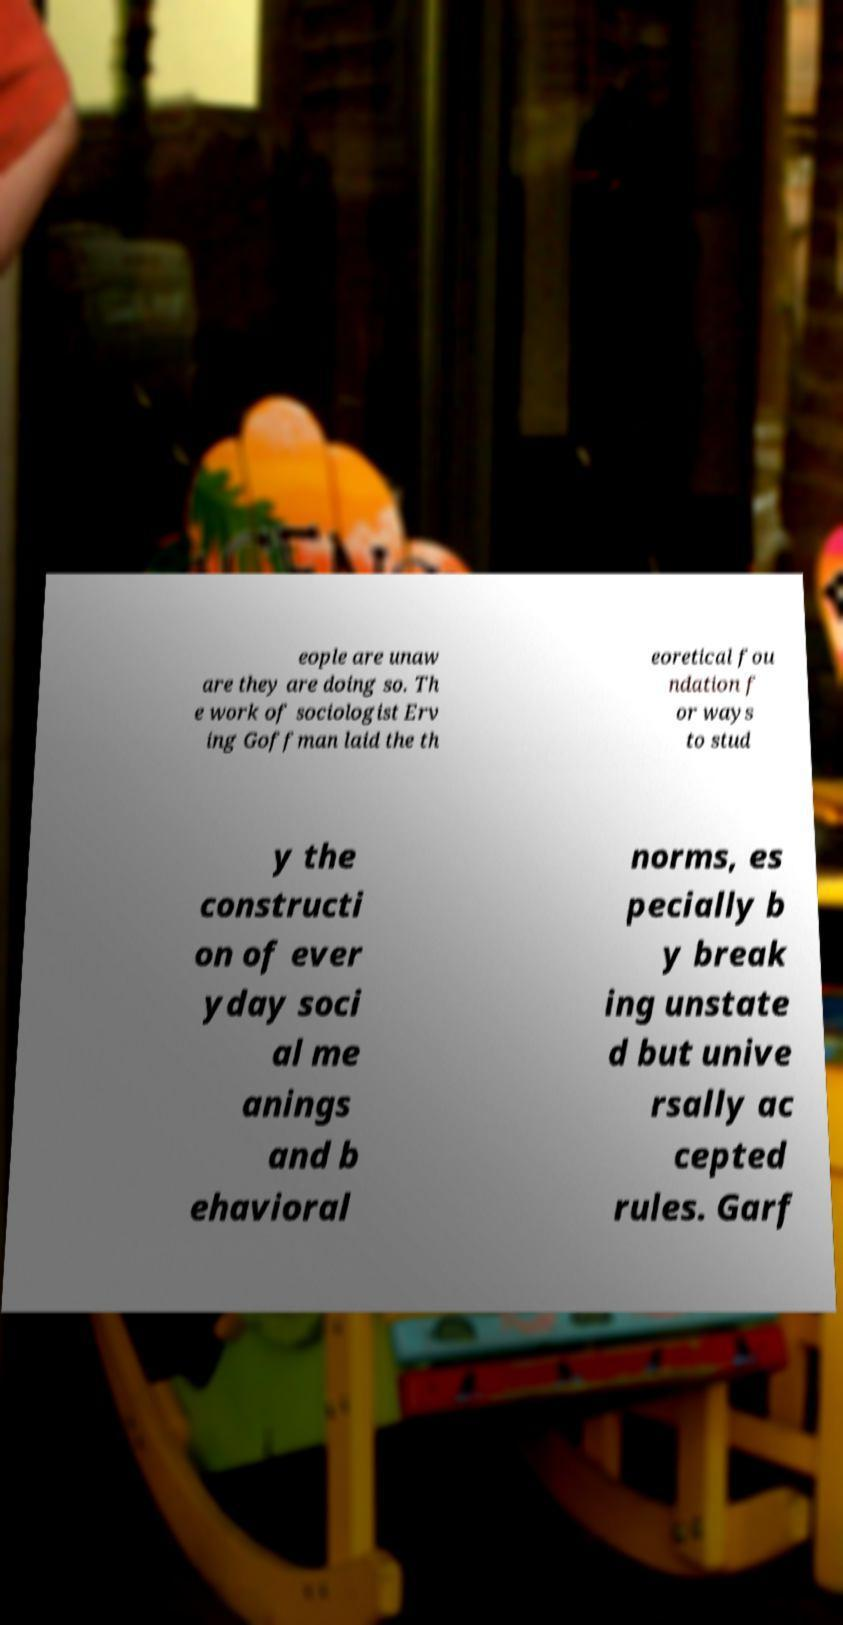Can you accurately transcribe the text from the provided image for me? eople are unaw are they are doing so. Th e work of sociologist Erv ing Goffman laid the th eoretical fou ndation f or ways to stud y the constructi on of ever yday soci al me anings and b ehavioral norms, es pecially b y break ing unstate d but unive rsally ac cepted rules. Garf 